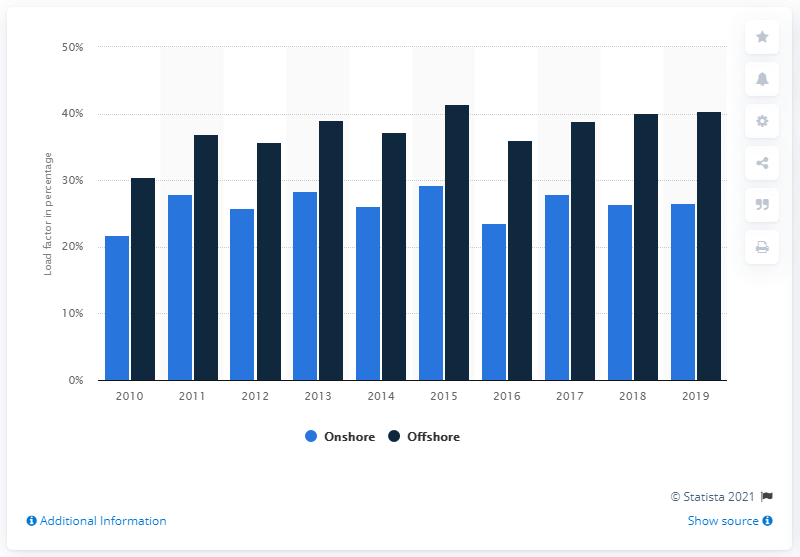Point out several critical features in this image. In 2019, the load factor of onshore and offshore wind was 26.6%. In 2019, the load factor of onshore and offshore wind was 40.4%. The load factor for electricity generation from both onshore and offshore wind in the UK began to fluctuate in 2010. 